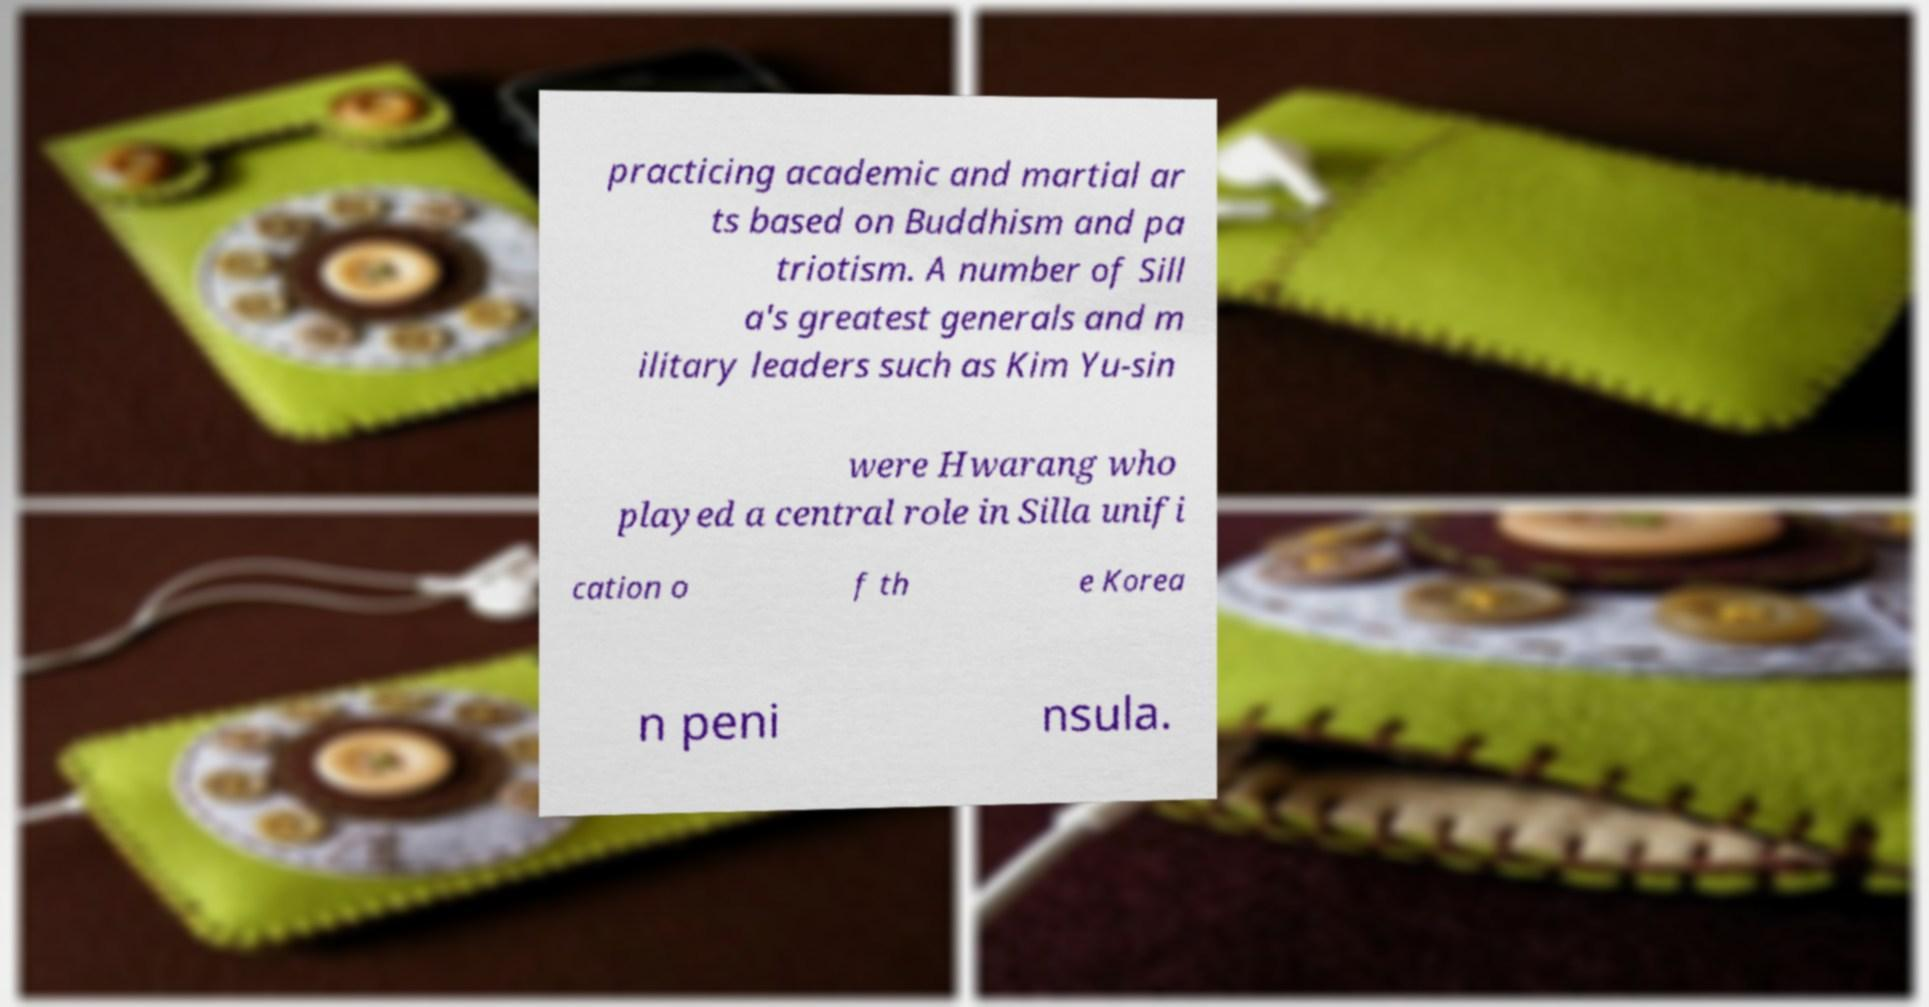I need the written content from this picture converted into text. Can you do that? practicing academic and martial ar ts based on Buddhism and pa triotism. A number of Sill a's greatest generals and m ilitary leaders such as Kim Yu-sin were Hwarang who played a central role in Silla unifi cation o f th e Korea n peni nsula. 